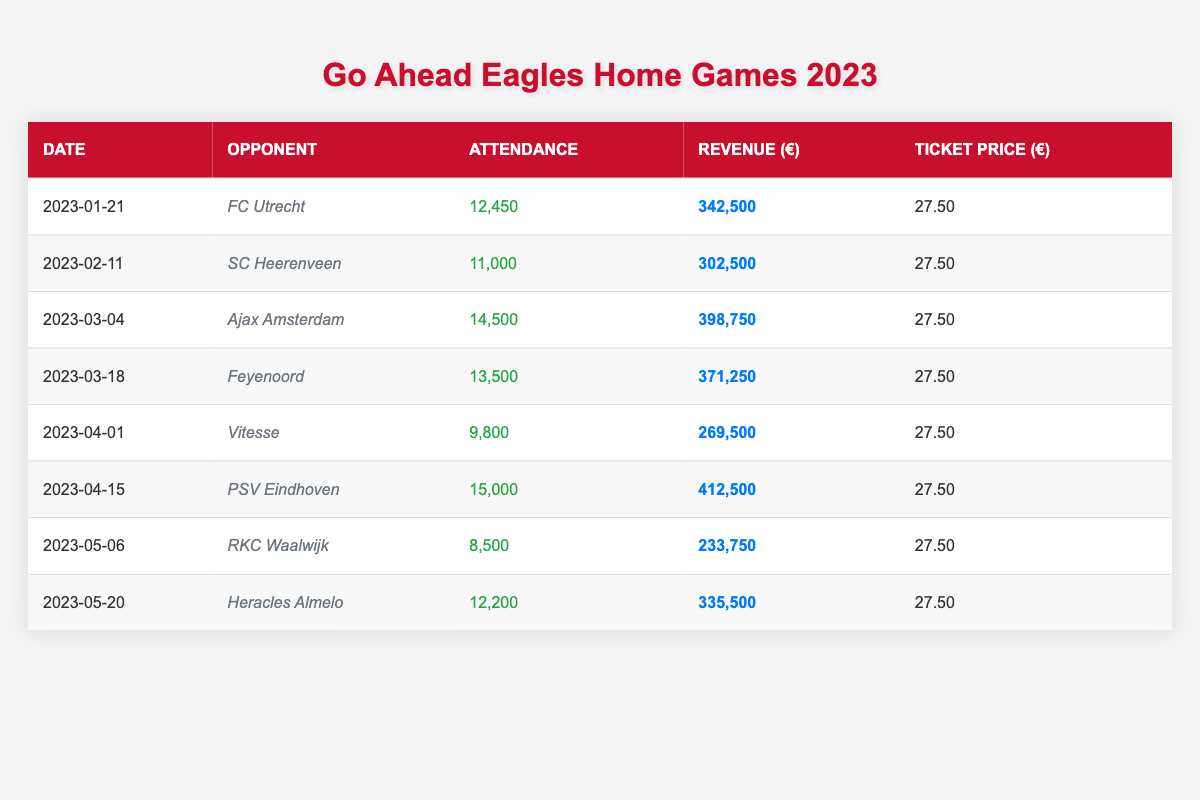What was the total attendance across all home games? To find the total attendance, we sum the attendance figures for each match: 12450 + 11000 + 14500 + 13500 + 9800 + 15000 + 8500 + 12200 = 103950.
Answer: 103950 Which opponent had the highest revenue match against Go Ahead Eagles? We compare the revenue figures for each match. The highest revenue was from the match against PSV Eindhoven, which had a revenue of €412,500.
Answer: PSV Eindhoven What is the average attendance for the home games played in 2023? To calculate the average attendance, sum the attendance figures and divide by the number of matches: (12450 + 11000 + 14500 + 13500 + 9800 + 15000 + 8500 + 12200) / 8 = 12962.5.
Answer: 12962.5 Did Go Ahead Eagles play against Ajax Amsterdam on a date later than February? Ajax Amsterdam was played on March 4, which is indeed later than February. Therefore, the statement is true.
Answer: Yes What was the difference between the highest and lowest attendance figures in the table? The highest attendance is 15,000 (vs PSV Eindhoven) and the lowest is 8,500 (vs RKC Waalwijk). The difference is 15000 - 8500 = 6500.
Answer: 6500 What percentage of the total revenue is generated from the match against Ajax Amsterdam? First, calculate the total revenue: 342500 + 302500 + 398750 + 371250 + 269500 + 412500 + 233750 + 335500 = 2,392,250. The revenue from Ajax is €398,750. Thus, the percentage is (398750 / 2392250) * 100 = approximately 16.63%.
Answer: 16.63% Were there more matches with attendance above 12,000 or below 12,000? The matches above 12,000 are against FC Utrecht, Ajax Amsterdam, Feyenoord, and PSV Eindhoven, totaling 4 matches. The matches below 12,000 are against SC Heerenveen, Vitesse, RKC Waalwijk, and Heracles Almelo, totaling 4 matches. Since they are equal, the answer is 4 vs 4.
Answer: Equal 